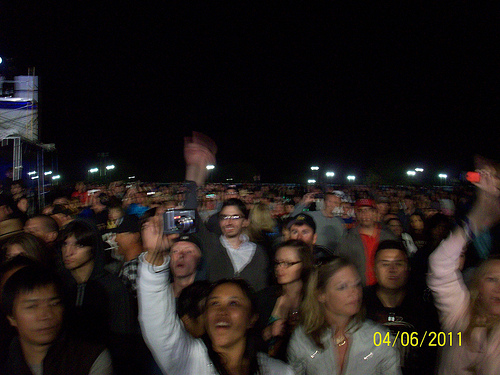<image>
Is the man to the left of the girl? No. The man is not to the left of the girl. From this viewpoint, they have a different horizontal relationship. 